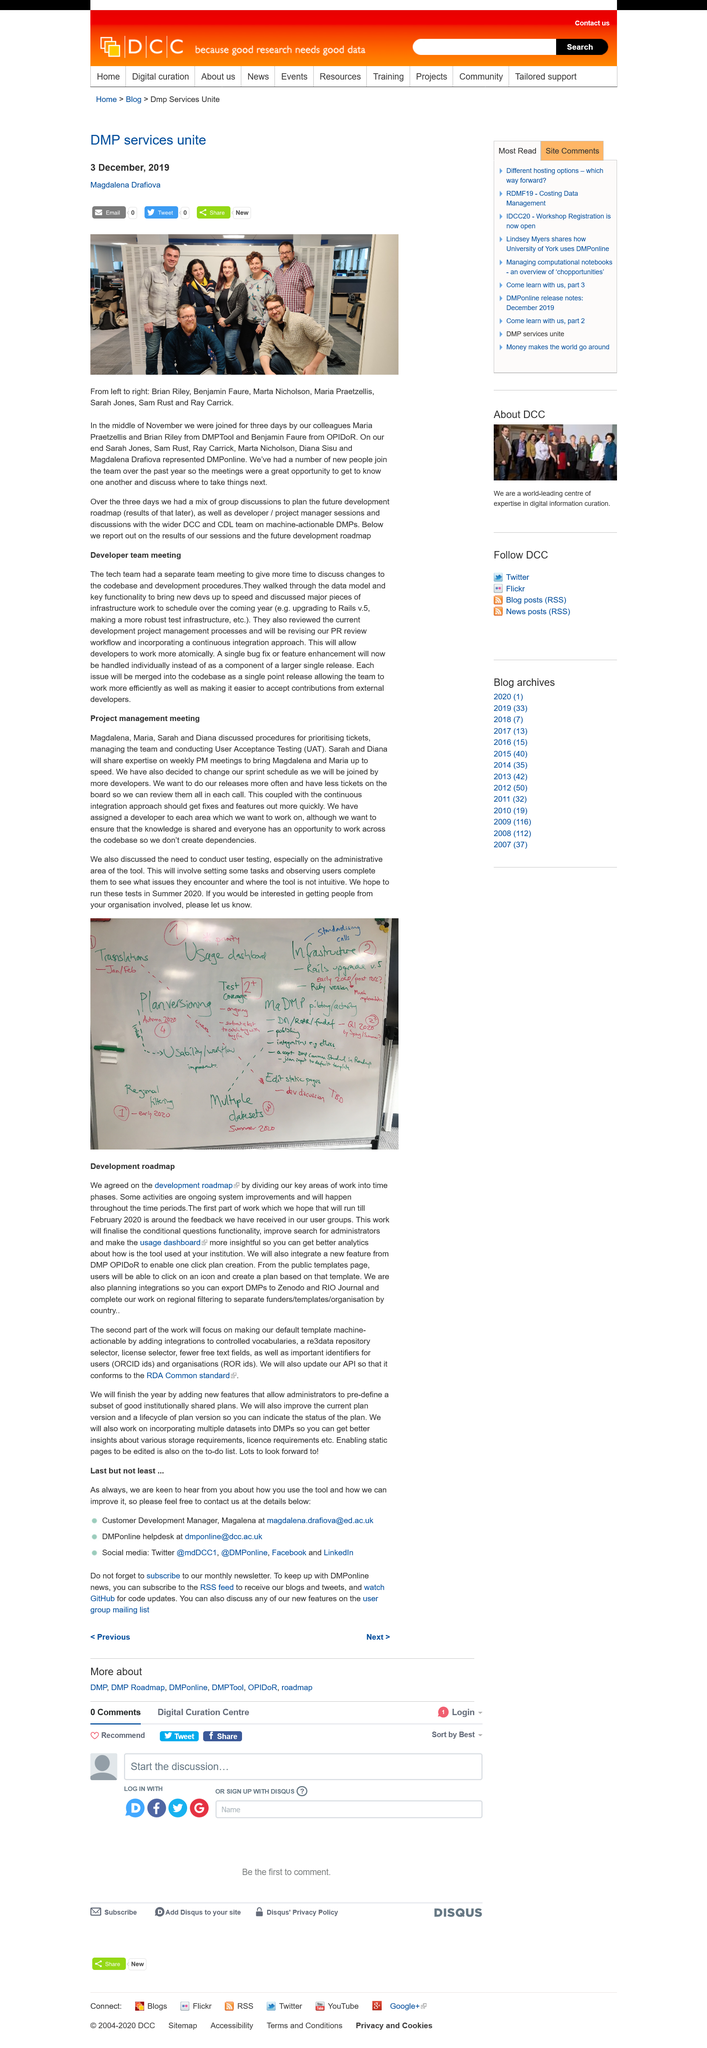Indicate a few pertinent items in this graphic. The integration of the new feature from DMP OPIDoR will be the creation of one-click plans. The platform will enable users to filter funders, templates, and organizations based on their country of origin, offering a new way to narrow down search results and easily find relevant information. The conditional questions functionality, improved search for administrators, and a more insightful usage dashboard will be finalized as stated in the roadmap. 